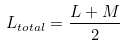Convert formula to latex. <formula><loc_0><loc_0><loc_500><loc_500>L _ { t o t a l } = { \frac { L + M } { 2 } }</formula> 